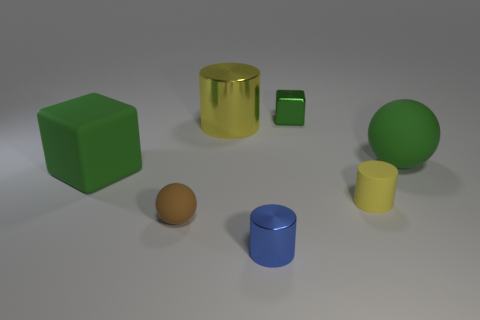How many green blocks must be subtracted to get 1 green blocks? 1 Subtract all small blue cylinders. How many cylinders are left? 2 Add 1 big purple spheres. How many objects exist? 8 Subtract all green spheres. How many spheres are left? 1 Add 6 small shiny things. How many small shiny things exist? 8 Subtract 1 brown spheres. How many objects are left? 6 Subtract all cylinders. How many objects are left? 4 Subtract 1 balls. How many balls are left? 1 Subtract all purple cylinders. Subtract all blue spheres. How many cylinders are left? 3 Subtract all purple balls. How many brown cubes are left? 0 